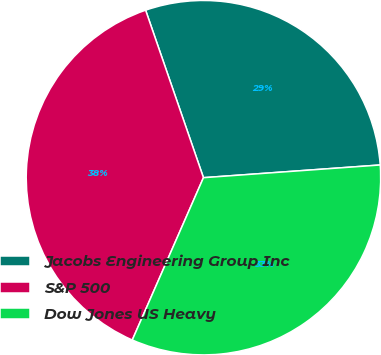<chart> <loc_0><loc_0><loc_500><loc_500><pie_chart><fcel>Jacobs Engineering Group Inc<fcel>S&P 500<fcel>Dow Jones US Heavy<nl><fcel>29.15%<fcel>38.13%<fcel>32.72%<nl></chart> 